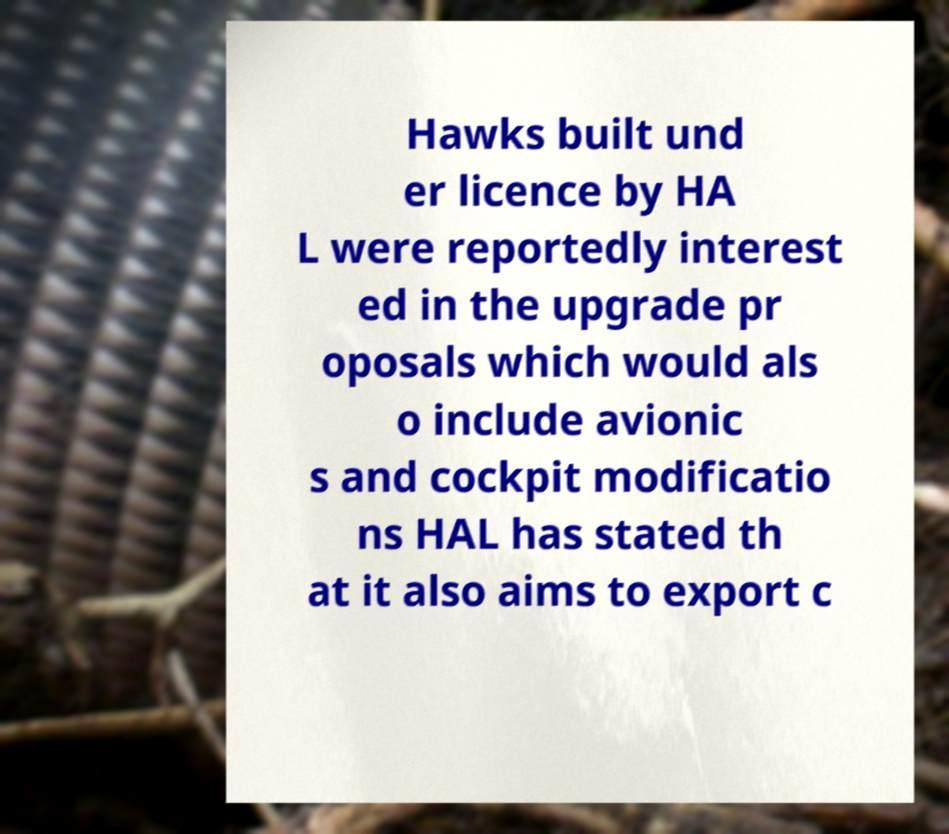What messages or text are displayed in this image? I need them in a readable, typed format. Hawks built und er licence by HA L were reportedly interest ed in the upgrade pr oposals which would als o include avionic s and cockpit modificatio ns HAL has stated th at it also aims to export c 